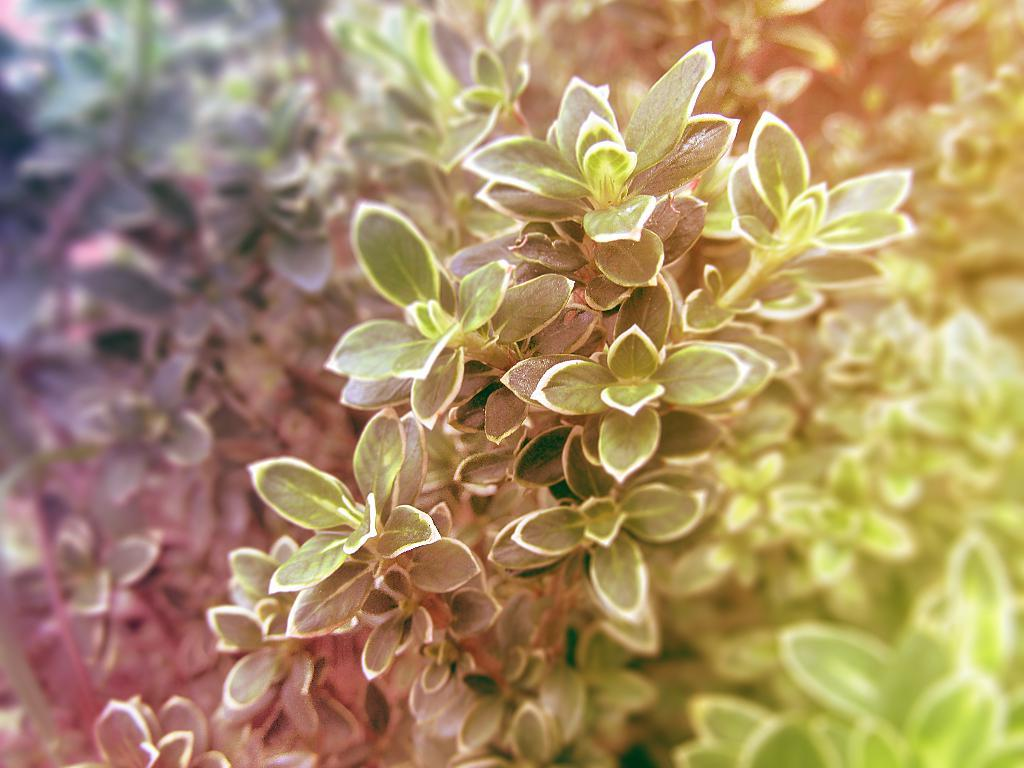What can be observed about the image itself? The image is edited. What type of vegetation is present in the image? There are plants with leaves in the image. How would you describe the background of the image? The background of the image is blurry. What type of stitch is being used to sew the leaves of the plants in the image? There is no stitching or sewing present in the image; the plants are depicted as they naturally appear. Can you see a pipe in the image? There is no pipe present in the image. Is there a guitar visible in the image? There is no guitar present in the image. 